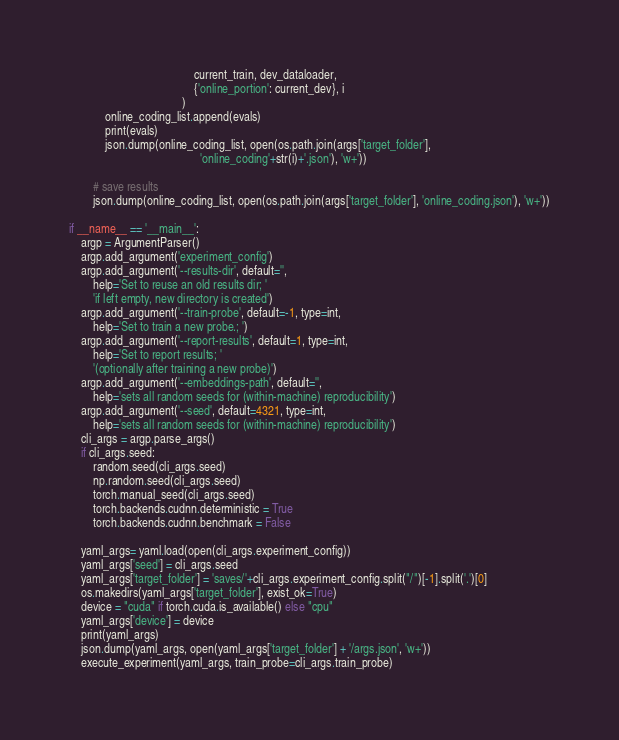Convert code to text. <code><loc_0><loc_0><loc_500><loc_500><_Python_>                                          current_train, dev_dataloader, 
                                          {'online_portion': current_dev}, i
                                      )
            online_coding_list.append(evals)
            print(evals)
            json.dump(online_coding_list, open(os.path.join(args['target_folder'],
                                            'online_coding'+str(i)+'.json'), 'w+'))

        # save results
        json.dump(online_coding_list, open(os.path.join(args['target_folder'], 'online_coding.json'), 'w+'))

if __name__ == '__main__':
    argp = ArgumentParser()
    argp.add_argument('experiment_config')
    argp.add_argument('--results-dir', default='',
        help='Set to reuse an old results dir; '
        'if left empty, new directory is created')
    argp.add_argument('--train-probe', default=-1, type=int,
        help='Set to train a new probe.; ')
    argp.add_argument('--report-results', default=1, type=int,
        help='Set to report results; '
        '(optionally after training a new probe)')
    argp.add_argument('--embeddings-path', default='',
        help='sets all random seeds for (within-machine) reproducibility')
    argp.add_argument('--seed', default=4321, type=int,
        help='sets all random seeds for (within-machine) reproducibility')
    cli_args = argp.parse_args()
    if cli_args.seed:
        random.seed(cli_args.seed)
        np.random.seed(cli_args.seed)
        torch.manual_seed(cli_args.seed)
        torch.backends.cudnn.deterministic = True
        torch.backends.cudnn.benchmark = False

    yaml_args= yaml.load(open(cli_args.experiment_config))
    yaml_args['seed'] = cli_args.seed
    yaml_args['target_folder'] = 'saves/'+cli_args.experiment_config.split("/")[-1].split('.')[0]
    os.makedirs(yaml_args['target_folder'], exist_ok=True)
    device = "cuda" if torch.cuda.is_available() else "cpu"
    yaml_args['device'] = device
    print(yaml_args)
    json.dump(yaml_args, open(yaml_args['target_folder'] + '/args.json', 'w+'))
    execute_experiment(yaml_args, train_probe=cli_args.train_probe)
</code> 